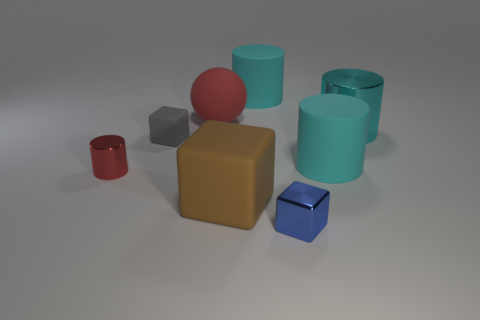Subtract all cyan cylinders. How many were subtracted if there are1cyan cylinders left? 2 Add 1 small purple blocks. How many objects exist? 9 Subtract all large brown rubber cubes. How many cubes are left? 2 Subtract 2 cylinders. How many cylinders are left? 2 Subtract all cyan cylinders. How many cylinders are left? 1 Subtract 1 red balls. How many objects are left? 7 Subtract all balls. How many objects are left? 7 Subtract all gray blocks. Subtract all blue spheres. How many blocks are left? 2 Subtract all green cylinders. How many red blocks are left? 0 Subtract all red matte balls. Subtract all gray matte things. How many objects are left? 6 